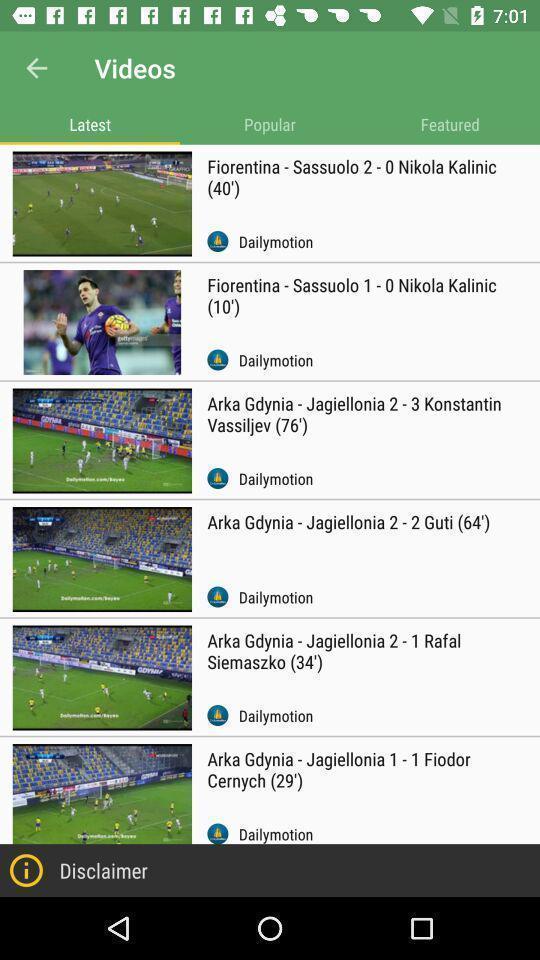Provide a textual representation of this image. Screen showing list of various latest videos. 